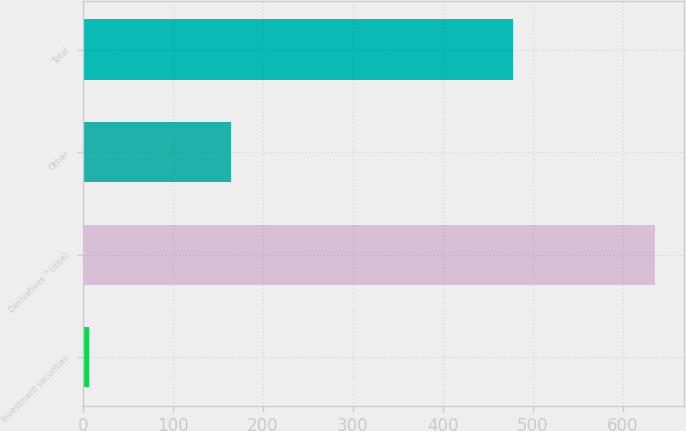Convert chart. <chart><loc_0><loc_0><loc_500><loc_500><bar_chart><fcel>Investment securities<fcel>Derivatives ^(d)(e)<fcel>Other<fcel>Total<nl><fcel>7<fcel>636<fcel>165<fcel>478<nl></chart> 